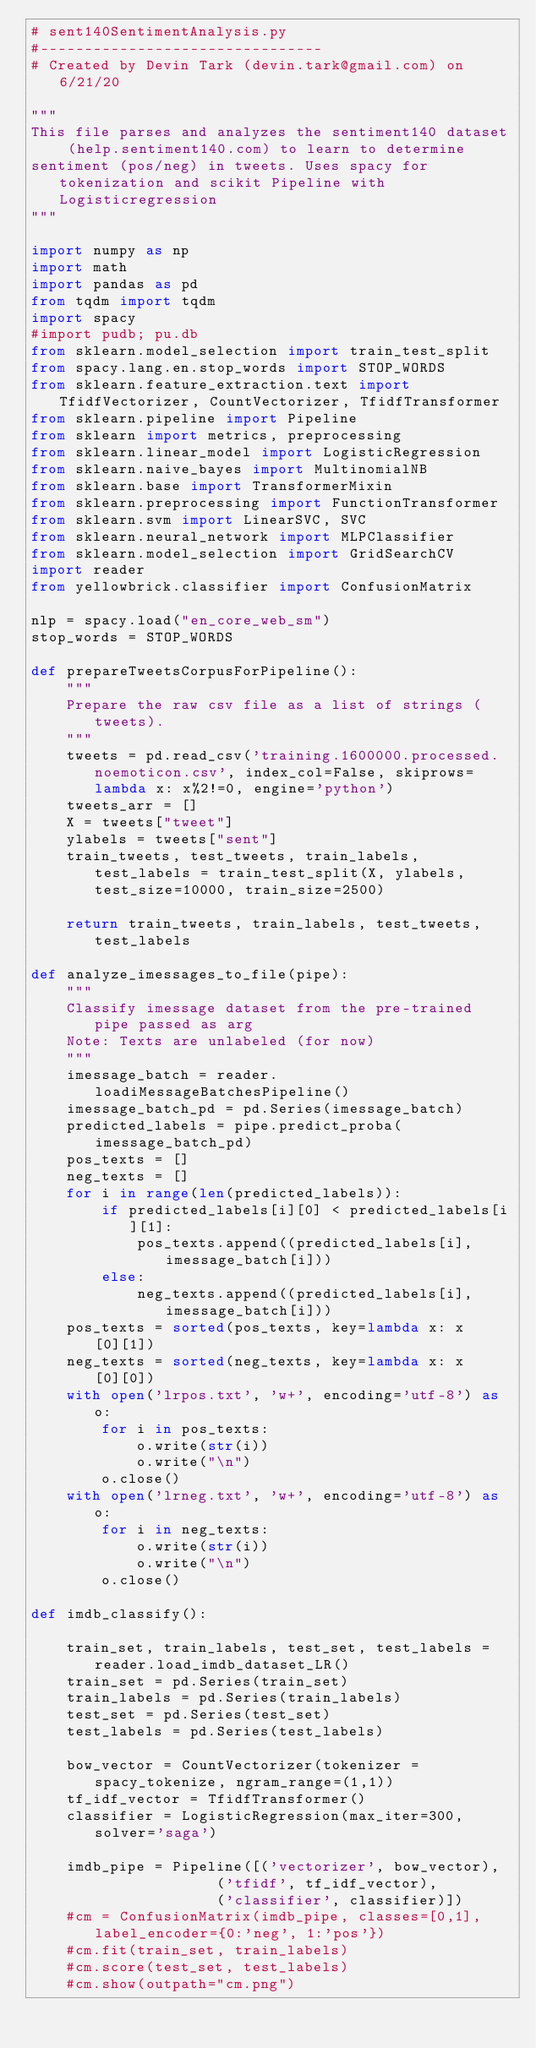<code> <loc_0><loc_0><loc_500><loc_500><_Python_># sent140SentimentAnalysis.py
#--------------------------------
# Created by Devin Tark (devin.tark@gmail.com) on 6/21/20

"""
This file parses and analyzes the sentiment140 dataset (help.sentiment140.com) to learn to determine
sentiment (pos/neg) in tweets. Uses spacy for tokenization and scikit Pipeline with Logisticregression
"""

import numpy as np
import math
import pandas as pd
from tqdm import tqdm
import spacy
#import pudb; pu.db
from sklearn.model_selection import train_test_split
from spacy.lang.en.stop_words import STOP_WORDS
from sklearn.feature_extraction.text import TfidfVectorizer, CountVectorizer, TfidfTransformer
from sklearn.pipeline import Pipeline
from sklearn import metrics, preprocessing
from sklearn.linear_model import LogisticRegression
from sklearn.naive_bayes import MultinomialNB
from sklearn.base import TransformerMixin
from sklearn.preprocessing import FunctionTransformer
from sklearn.svm import LinearSVC, SVC
from sklearn.neural_network import MLPClassifier
from sklearn.model_selection import GridSearchCV
import reader
from yellowbrick.classifier import ConfusionMatrix

nlp = spacy.load("en_core_web_sm")
stop_words = STOP_WORDS

def prepareTweetsCorpusForPipeline():
    """
    Prepare the raw csv file as a list of strings (tweets).
    """
    tweets = pd.read_csv('training.1600000.processed.noemoticon.csv', index_col=False, skiprows=lambda x: x%2!=0, engine='python')
    tweets_arr = []
    X = tweets["tweet"]
    ylabels = tweets["sent"]
    train_tweets, test_tweets, train_labels, test_labels = train_test_split(X, ylabels, test_size=10000, train_size=2500)

    return train_tweets, train_labels, test_tweets, test_labels

def analyze_imessages_to_file(pipe):
    """
    Classify imessage dataset from the pre-trained pipe passed as arg
    Note: Texts are unlabeled (for now)
    """
    imessage_batch = reader.loadiMessageBatchesPipeline()
    imessage_batch_pd = pd.Series(imessage_batch)
    predicted_labels = pipe.predict_proba(imessage_batch_pd)
    pos_texts = []
    neg_texts = []
    for i in range(len(predicted_labels)):
        if predicted_labels[i][0] < predicted_labels[i][1]:
            pos_texts.append((predicted_labels[i], imessage_batch[i]))
        else:
            neg_texts.append((predicted_labels[i], imessage_batch[i]))
    pos_texts = sorted(pos_texts, key=lambda x: x[0][1])
    neg_texts = sorted(neg_texts, key=lambda x: x[0][0])
    with open('lrpos.txt', 'w+', encoding='utf-8') as o:
        for i in pos_texts:
            o.write(str(i))
            o.write("\n")
        o.close()
    with open('lrneg.txt', 'w+', encoding='utf-8') as o:
        for i in neg_texts:
            o.write(str(i))
            o.write("\n")
        o.close()

def imdb_classify():

    train_set, train_labels, test_set, test_labels = reader.load_imdb_dataset_LR()
    train_set = pd.Series(train_set)
    train_labels = pd.Series(train_labels)
    test_set = pd.Series(test_set)
    test_labels = pd.Series(test_labels)

    bow_vector = CountVectorizer(tokenizer = spacy_tokenize, ngram_range=(1,1))
    tf_idf_vector = TfidfTransformer()
    classifier = LogisticRegression(max_iter=300, solver='saga')

    imdb_pipe = Pipeline([('vectorizer', bow_vector),
                     ('tfidf', tf_idf_vector),
                     ('classifier', classifier)])
    #cm = ConfusionMatrix(imdb_pipe, classes=[0,1], label_encoder={0:'neg', 1:'pos'})
    #cm.fit(train_set, train_labels)
    #cm.score(test_set, test_labels)
    #cm.show(outpath="cm.png")</code> 